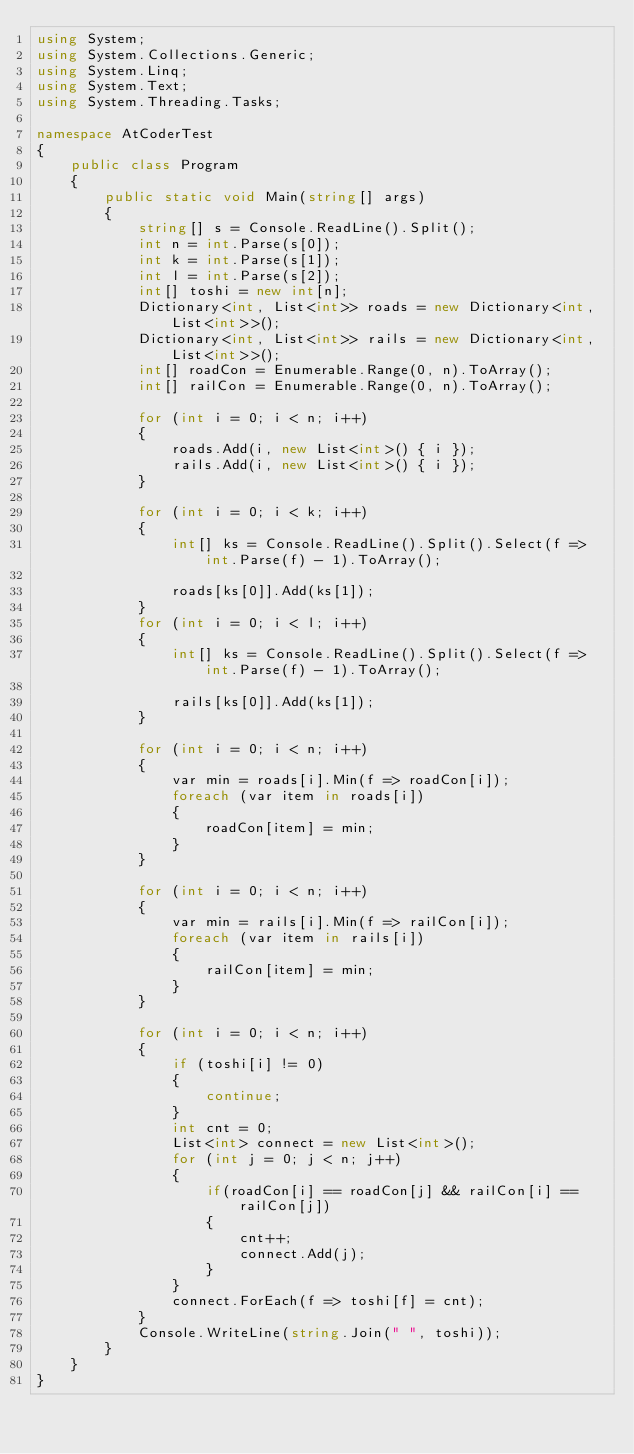<code> <loc_0><loc_0><loc_500><loc_500><_C#_>using System;
using System.Collections.Generic;
using System.Linq;
using System.Text;
using System.Threading.Tasks;

namespace AtCoderTest
{
    public class Program
    {
        public static void Main(string[] args)
        {
            string[] s = Console.ReadLine().Split();
            int n = int.Parse(s[0]);
            int k = int.Parse(s[1]);
            int l = int.Parse(s[2]);
            int[] toshi = new int[n];
            Dictionary<int, List<int>> roads = new Dictionary<int, List<int>>();
            Dictionary<int, List<int>> rails = new Dictionary<int, List<int>>();
            int[] roadCon = Enumerable.Range(0, n).ToArray();
            int[] railCon = Enumerable.Range(0, n).ToArray();

            for (int i = 0; i < n; i++)
            {
                roads.Add(i, new List<int>() { i });
                rails.Add(i, new List<int>() { i });
            }

            for (int i = 0; i < k; i++)
            {
                int[] ks = Console.ReadLine().Split().Select(f => int.Parse(f) - 1).ToArray();

                roads[ks[0]].Add(ks[1]);
            }
            for (int i = 0; i < l; i++)
            {
                int[] ks = Console.ReadLine().Split().Select(f => int.Parse(f) - 1).ToArray();

                rails[ks[0]].Add(ks[1]);
            }

            for (int i = 0; i < n; i++)
            {
                var min = roads[i].Min(f => roadCon[i]);
                foreach (var item in roads[i])
                {
                    roadCon[item] = min;
                }
            }

            for (int i = 0; i < n; i++)
            {
                var min = rails[i].Min(f => railCon[i]);
                foreach (var item in rails[i])
                {
                    railCon[item] = min;
                }
            }

            for (int i = 0; i < n; i++)
            {
                if (toshi[i] != 0)
                {
                    continue;
                }
                int cnt = 0;
                List<int> connect = new List<int>();
                for (int j = 0; j < n; j++)
                {
                    if(roadCon[i] == roadCon[j] && railCon[i] == railCon[j])
                    {
                        cnt++;
                        connect.Add(j);
                    }
                }
                connect.ForEach(f => toshi[f] = cnt);
            }
            Console.WriteLine(string.Join(" ", toshi));
        }
    }
}
</code> 